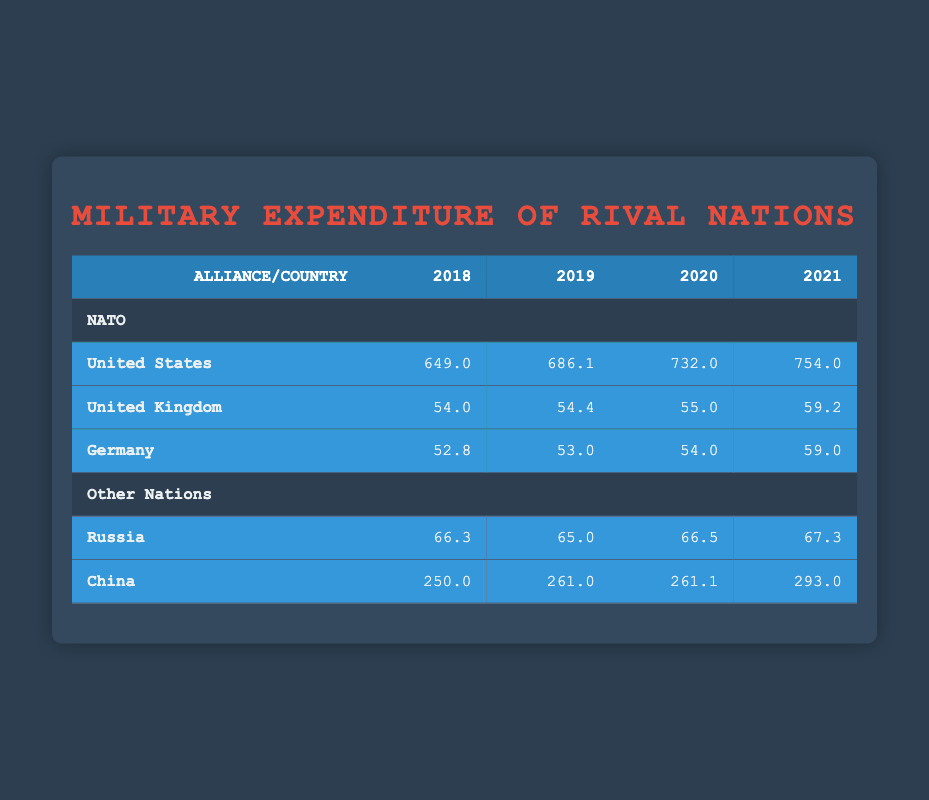What was the military expenditure of the United States in 2020? The table shows that the military expenditure of the United States in 2020 is 732.0.
Answer: 732.0 Which country in NATO had the highest expenditure in 2021? The table indicates that the United States had the highest military expenditure in 2021 at 754.0.
Answer: United States What is the total military expenditure of Germany from 2018 to 2021? To find the total, we sum the expenditures for Germany: 52.8 + 53.0 + 54.0 + 59.0 = 218.8.
Answer: 218.8 Did China's military expenditure increase every year from 2018 to 2021? By checking the values, we see that China's expenditures were 250.0 in 2018, 261.0 in 2019, 261.1 in 2020, and 293.0 in 2021. The expenditure from 2019 to 2020 barely increased, so the statement is false.
Answer: No How much more did the United States spend on military in 2019 compared to Russia? In 2019, the United States spent 686.1 and Russia spent 65.0. The difference is 686.1 - 65.0 = 621.1.
Answer: 621.1 What is the average military expenditure of NATO countries in 2018? To find the average, we first add the expenditures for the NATO countries in 2018: 649.0 (US) + 54.0 (UK) + 52.8 (Germany) = 755.8. There are 3 countries, so we divide by 3: 755.8 / 3 = 251.93.
Answer: 251.93 Which country had a military expenditure of 67.3 in 2021? The table shows that Russia had a military expenditure of 67.3 in 2021.
Answer: Russia What was the change in China's military expenditure from 2019 to 2021? In 2019, China's expenditure was 261.0 and in 2021 it was 293.0. The change is 293.0 - 261.0 = 32.0, indicating an increase.
Answer: 32.0 Did the military expenditure of the United Kingdom exceed that of Russia in 2019? According to the table, the United Kingdom spent 54.4 while Russia spent 65.0 in 2019, which indicates the UK expenditure did not exceed that of Russia.
Answer: No 